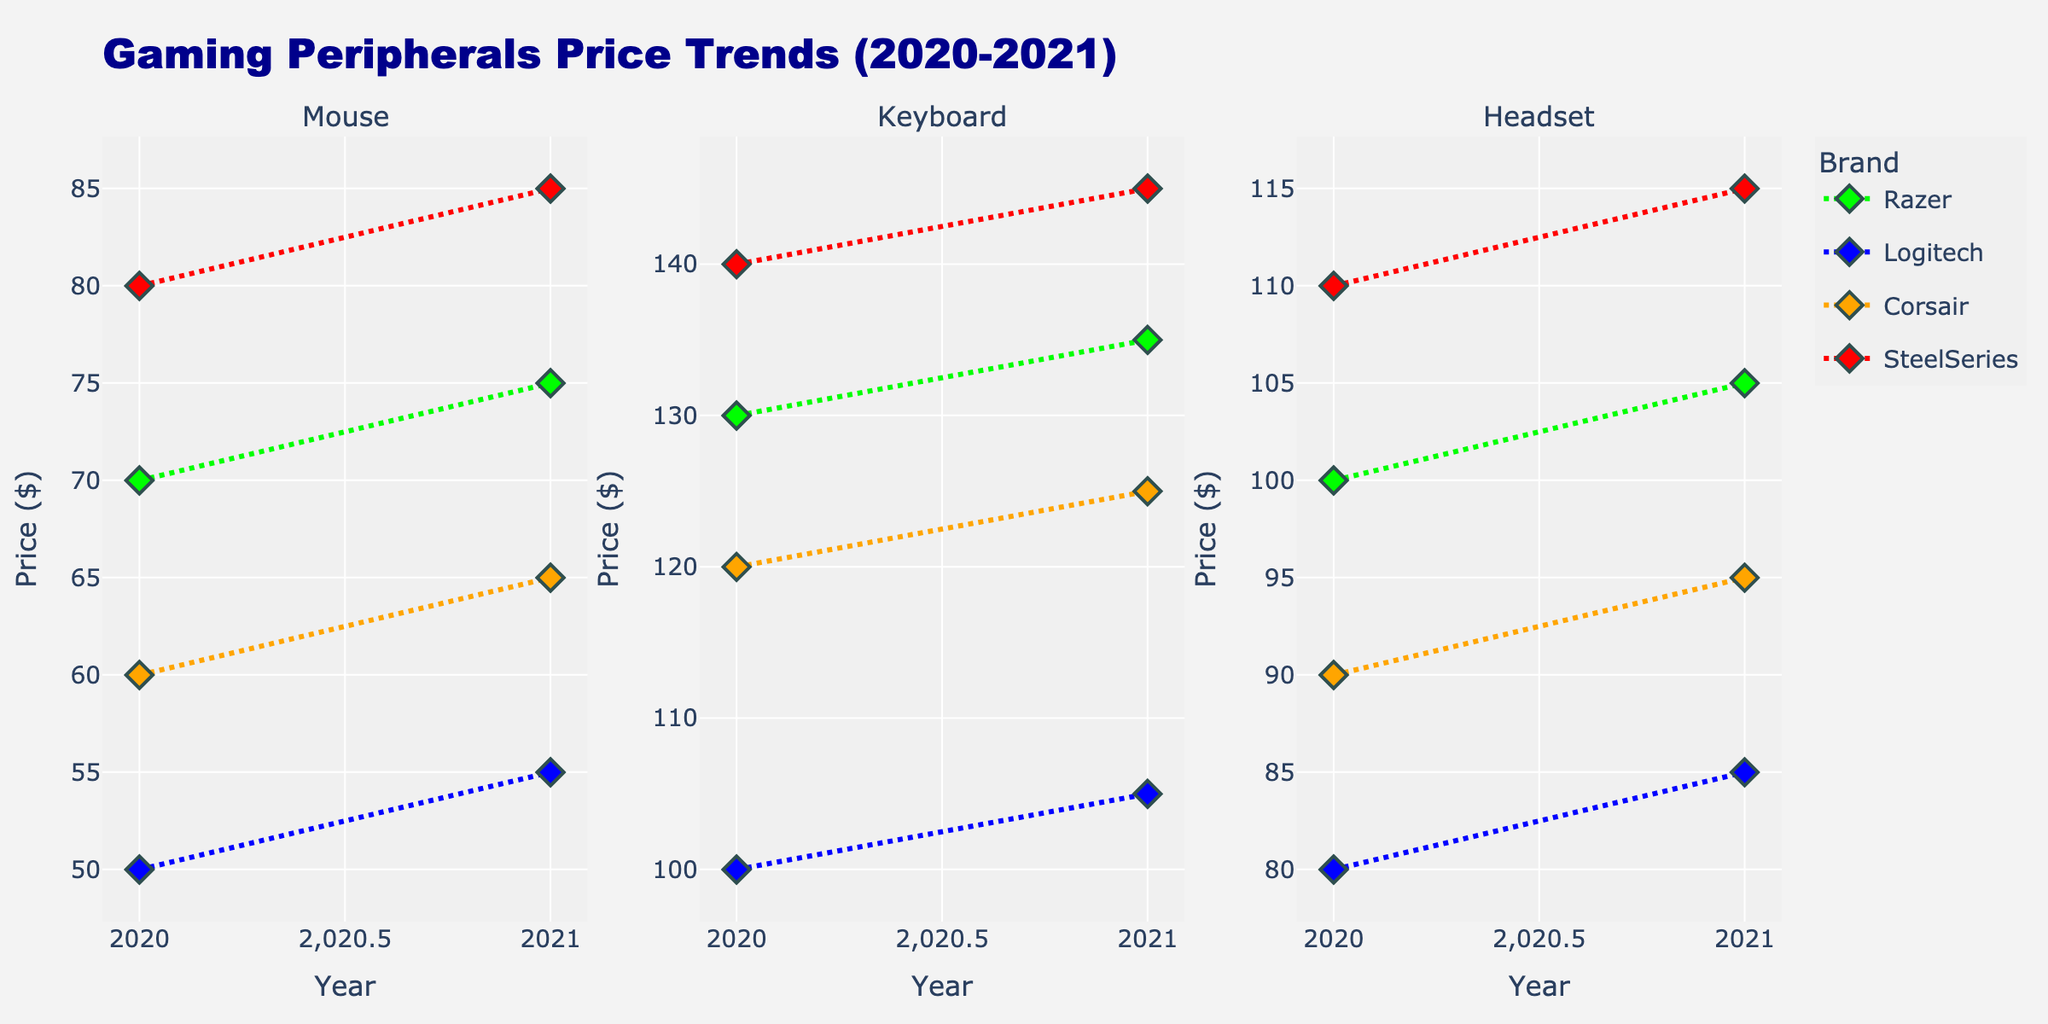What's the title of the figure? The title of the figure is written at the top center of the plot. It is "Gaming Peripherals Price Trends (2020-2021)".
Answer: Gaming Peripherals Price Trends (2020-2021) Which company had the most expensive mouse in 2020? Look at the "Mouse" subplot for the year 2020. The highest price mouse belongs to SteelSeries at $79.99.
Answer: SteelSeries What is the color used to represent Razer in the plots? Identify the markers and line colors corresponding to Razer in the plot. The color used for Razer is green.
Answer: green How did the price of Logitech keyboards change from 2020 to 2021? Look at the "Keyboard" subplot for Logitech. The price increased from $99.99 in 2020 to $104.99 in 2021. The price increased by $5.00.
Answer: increased by $5.00 Comparing the prices in 2021, which category had the smallest difference in price between brands? Examine the price ranges of each subplot for 2021. The "Mouse" category has the smallest range from $54.99 to $84.99, a difference of $30.00.
Answer: Mouse Which category had the most expensive item overall? Look at all subplots and find the highest price point. The most expensive item is in "Keyboard" from SteelSeries at $144.99 in 2021.
Answer: Keyboard What is the average price of Corsair products in 2021 across all categories? Sum the prices of Corsair products in 2021 and divide by the number of products. The prices are $64.99 (Mouse), $124.99 (Keyboard), and $94.99 (Headset). The average is (64.99 + 124.99 + 94.99) / 3 = 284.97 / 3 ≈ $95.00.
Answer: $95.00 Which brand had the smallest price increase for headsets from 2020 to 2021? Compare the price changes of all brands in the "Headset" subplot. Logitech had the smallest increase from $79.99 to $84.99, a difference of $5.00.
Answer: Logitech 